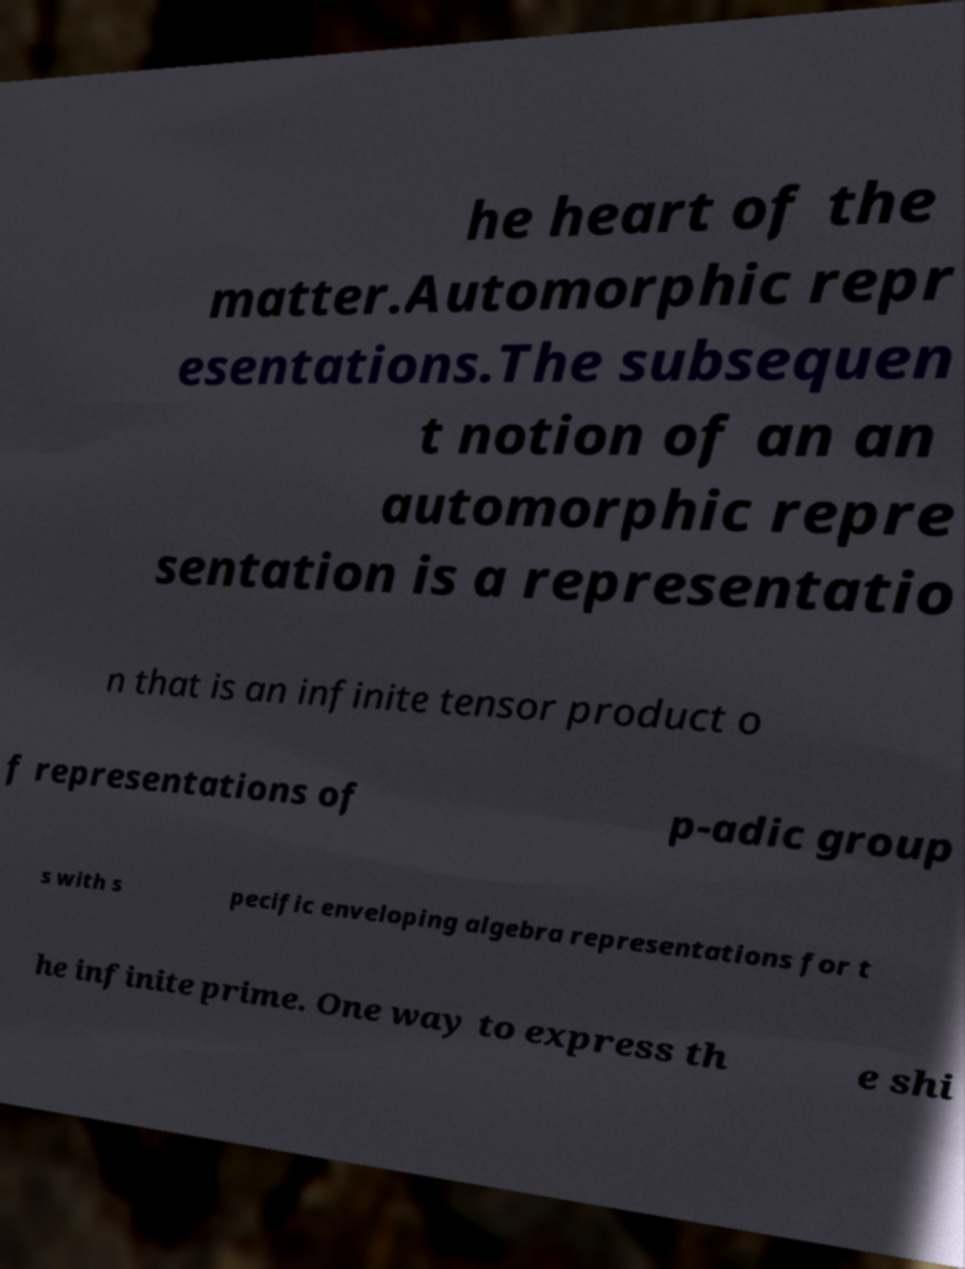I need the written content from this picture converted into text. Can you do that? he heart of the matter.Automorphic repr esentations.The subsequen t notion of an an automorphic repre sentation is a representatio n that is an infinite tensor product o f representations of p-adic group s with s pecific enveloping algebra representations for t he infinite prime. One way to express th e shi 